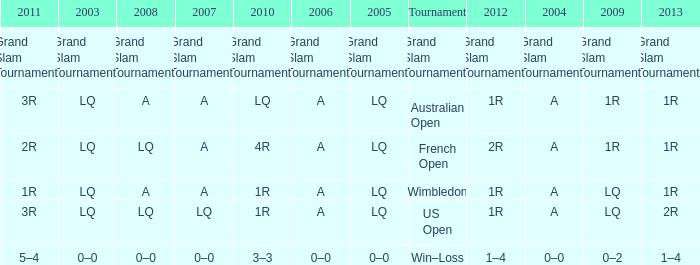Which tournament has a 2013 of 1r, and a 2012 of 1r? Australian Open, Wimbledon. 